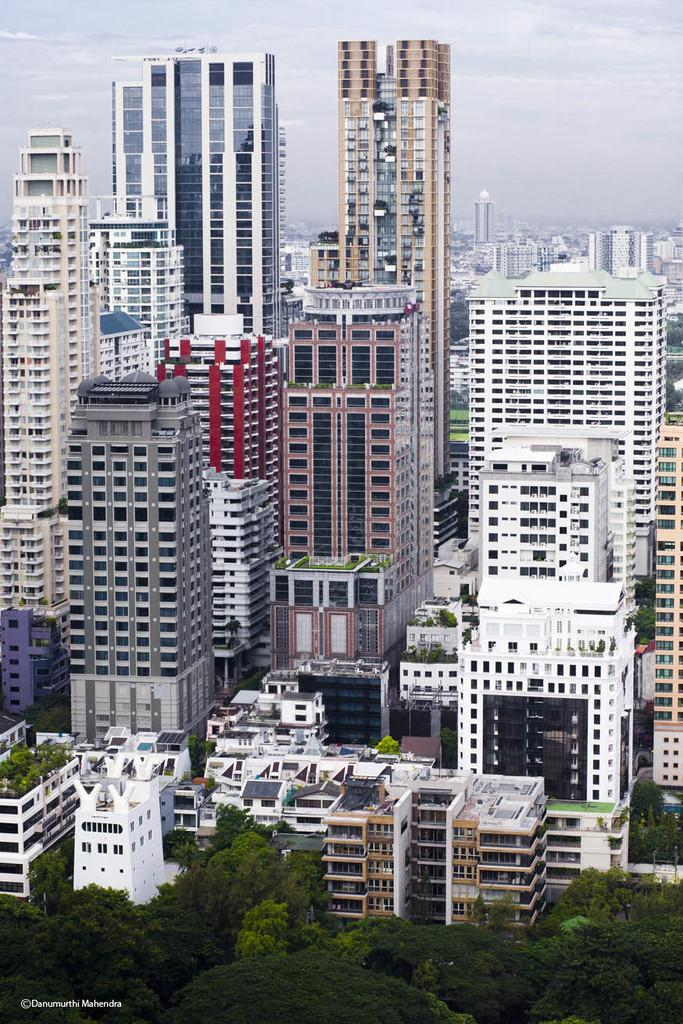What type of natural elements can be seen in the image? There are trees in the image. What type of man-made structures are present in the image? There are buildings in the image. What is visible in the sky in the image? There are clouds in the image. Where can some text be found in the image? There is some text in the bottom left hand corner of the image. Can you tell me how many friends are sitting on the tree in the image? There are no friends or people present in the image; it features trees, buildings, clouds, and text. What type of frog can be seen jumping on the building in the image? There is no frog present in the image; it features trees, buildings, clouds, and text. 